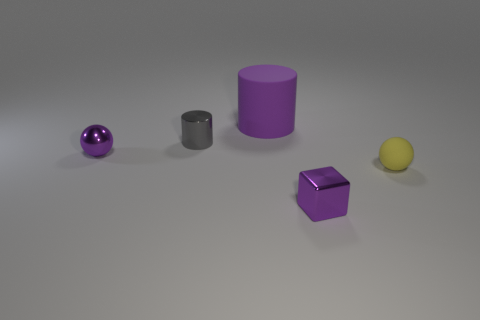Is the big purple rubber thing the same shape as the yellow matte thing?
Provide a succinct answer. No. Are there an equal number of purple metal spheres that are to the right of the tiny yellow sphere and gray shiny spheres?
Give a very brief answer. Yes. The big thing has what shape?
Make the answer very short. Cylinder. Are there any other things that have the same color as the matte sphere?
Provide a short and direct response. No. Is the size of the metal object that is in front of the metallic sphere the same as the ball on the left side of the yellow object?
Provide a short and direct response. Yes. What is the shape of the small thing that is behind the small ball left of the purple cube?
Give a very brief answer. Cylinder. There is a gray metal thing; is it the same size as the ball that is right of the small cube?
Offer a terse response. Yes. There is a thing on the right side of the purple object in front of the small ball that is on the left side of the purple cube; what is its size?
Provide a succinct answer. Small. What number of objects are either tiny objects that are on the left side of the large purple cylinder or small purple cubes?
Ensure brevity in your answer.  3. There is a small ball right of the large purple matte cylinder; what number of small cylinders are right of it?
Ensure brevity in your answer.  0. 